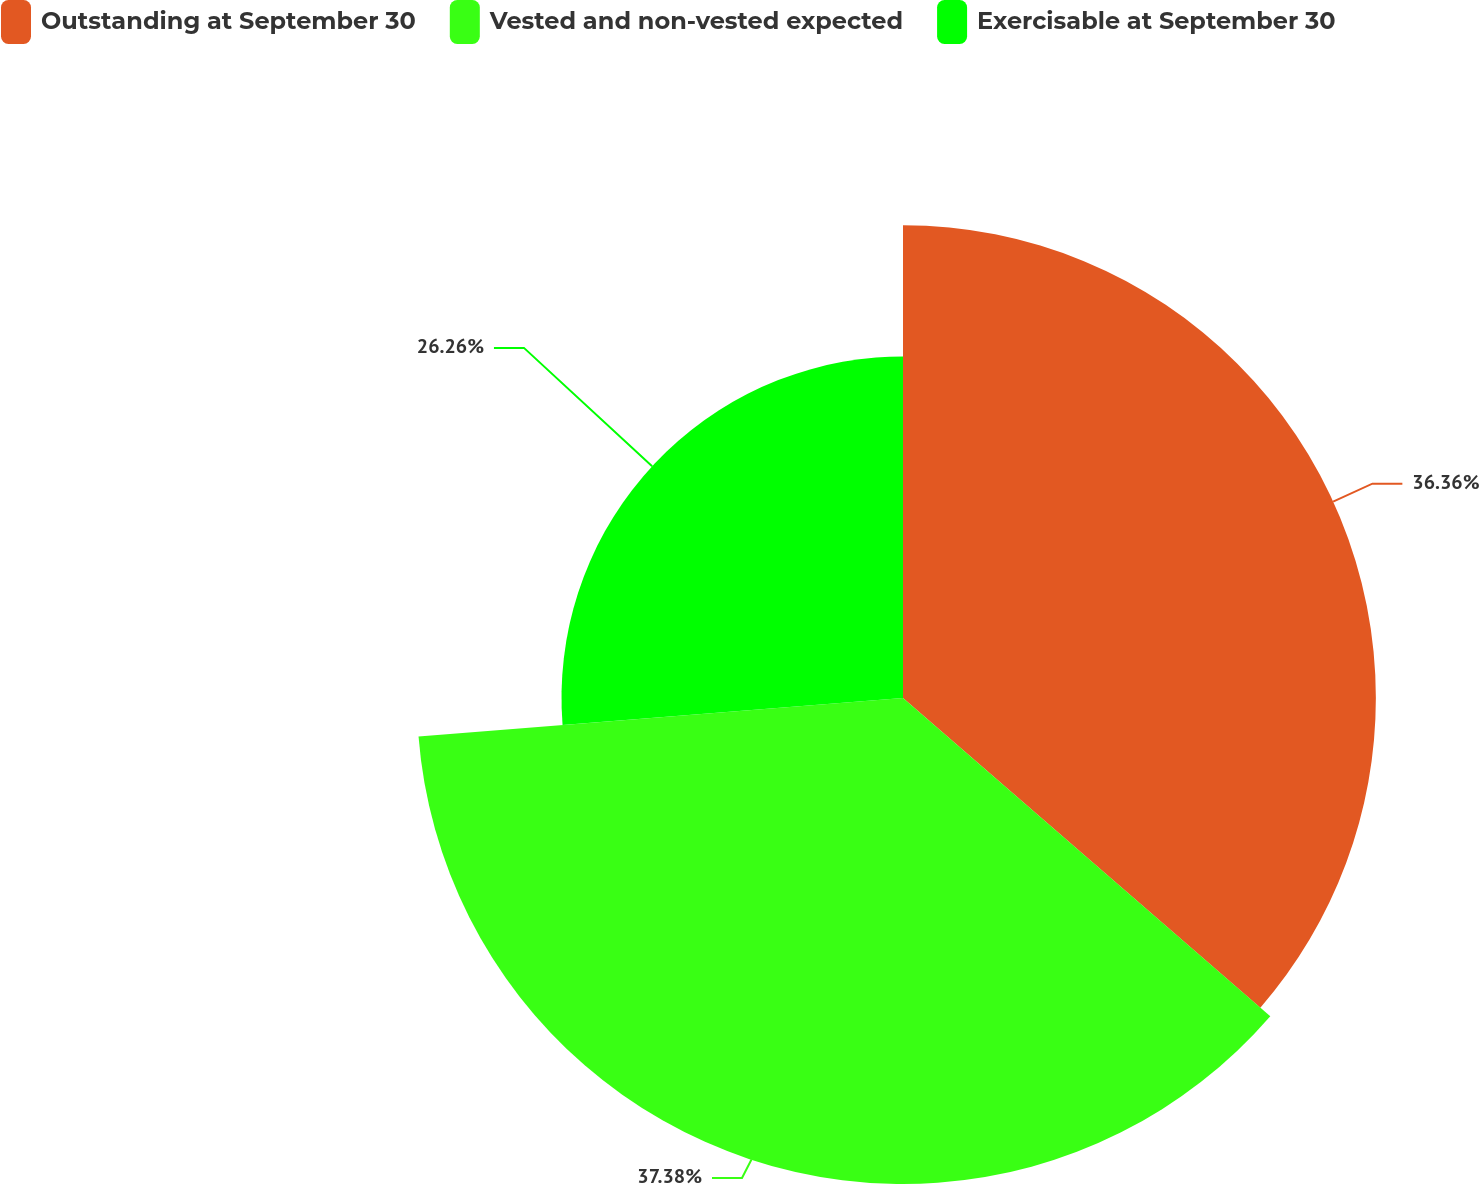Convert chart to OTSL. <chart><loc_0><loc_0><loc_500><loc_500><pie_chart><fcel>Outstanding at September 30<fcel>Vested and non-vested expected<fcel>Exercisable at September 30<nl><fcel>36.36%<fcel>37.37%<fcel>26.26%<nl></chart> 